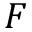<formula> <loc_0><loc_0><loc_500><loc_500>F</formula> 